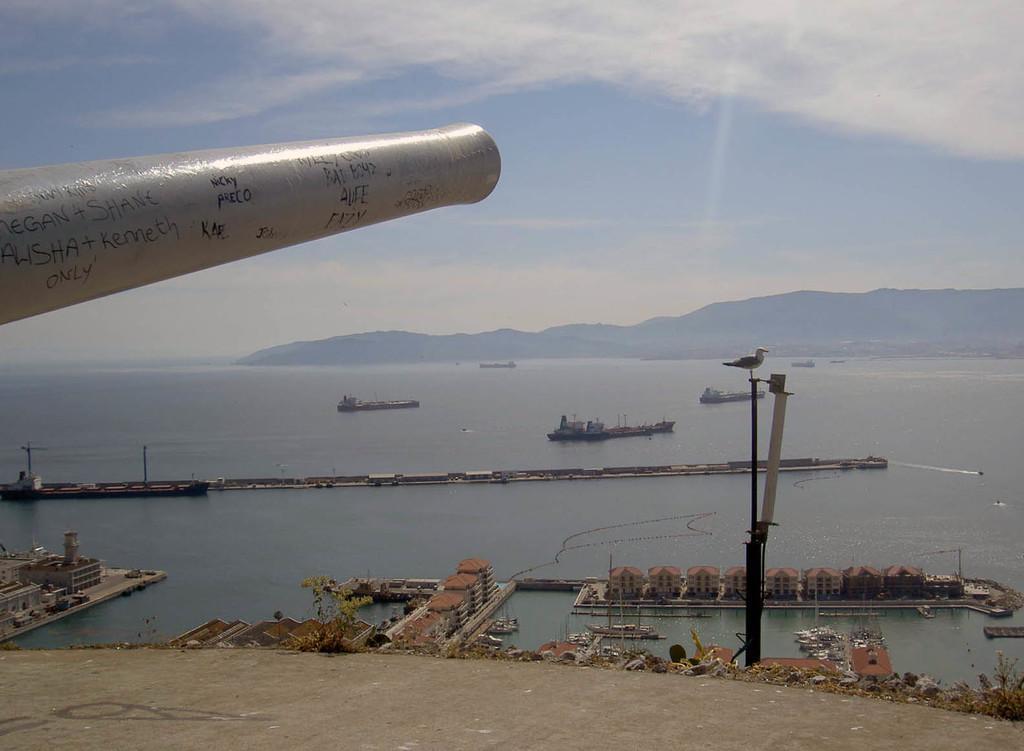Can you describe this image briefly? In this picture there is a canon pipe in the front of the image. Behind there are some small shed houses in the sea water and a long bridge. In the background there are some military boats and mountains. 